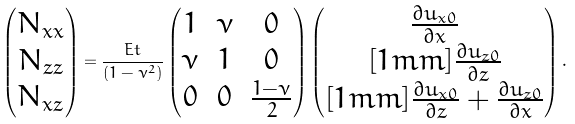Convert formula to latex. <formula><loc_0><loc_0><loc_500><loc_500>\begin{pmatrix} N _ { x x } \\ N _ { z z } \\ N _ { x z } \\ \end{pmatrix} = \frac { E t } { ( 1 - \nu ^ { 2 } ) } \begin{pmatrix} 1 & \nu & 0 \\ \nu & 1 & 0 \\ 0 & 0 & \frac { 1 - \nu } { 2 } \end{pmatrix} \begin{pmatrix} \frac { \partial u _ { x 0 } } { \partial x } \\ [ 1 m m ] \frac { \partial u _ { z 0 } } { \partial z } \\ [ 1 m m ] \frac { \partial u _ { x 0 } } { \partial z } + \frac { \partial u _ { z 0 } } { \partial x } \\ \end{pmatrix} .</formula> 